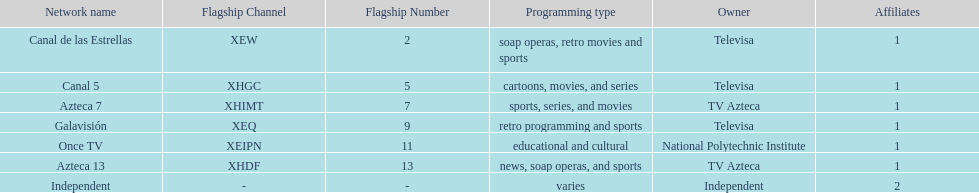Who is the only network owner listed in a consecutive order in the chart? Televisa. Would you be able to parse every entry in this table? {'header': ['Network name', 'Flagship Channel', 'Flagship Number', 'Programming type', 'Owner', 'Affiliates'], 'rows': [['Canal de las Estrellas', 'XEW', '2', 'soap operas, retro movies and sports', 'Televisa', '1'], ['Canal 5', 'XHGC', '5', 'cartoons, movies, and series', 'Televisa', '1'], ['Azteca 7', 'XHIMT', '7', 'sports, series, and movies', 'TV Azteca', '1'], ['Galavisión', 'XEQ', '9', 'retro programming and sports', 'Televisa', '1'], ['Once TV', 'XEIPN', '11', 'educational and cultural', 'National Polytechnic Institute', '1'], ['Azteca 13', 'XHDF', '13', 'news, soap operas, and sports', 'TV Azteca', '1'], ['Independent', '-', '-', 'varies', 'Independent', '2']]} 